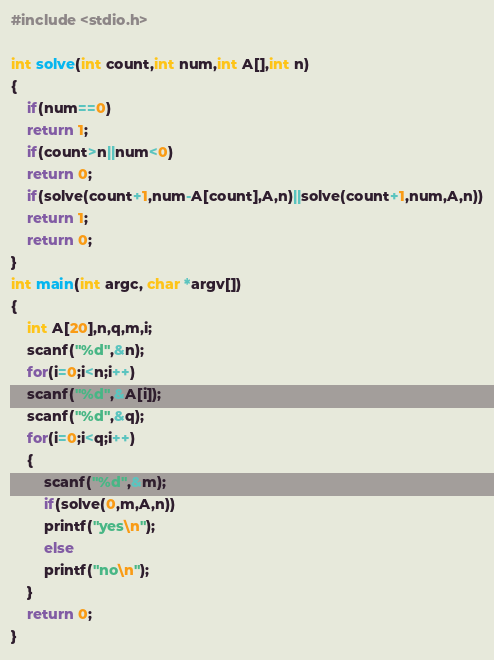<code> <loc_0><loc_0><loc_500><loc_500><_C_>#include <stdio.h>

int solve(int count,int num,int A[],int n)
{
	if(num==0)
	return 1;
	if(count>n||num<0)
	return 0;
	if(solve(count+1,num-A[count],A,n)||solve(count+1,num,A,n))
	return 1;
	return 0;
}
int main(int argc, char *argv[])
{
	int A[20],n,q,m,i;
	scanf("%d",&n);
	for(i=0;i<n;i++)
	scanf("%d",&A[i]);
	scanf("%d",&q);
	for(i=0;i<q;i++)
	{
		scanf("%d",&m);
		if(solve(0,m,A,n))
		printf("yes\n");
		else
		printf("no\n");
	}
	return 0;
}
</code> 